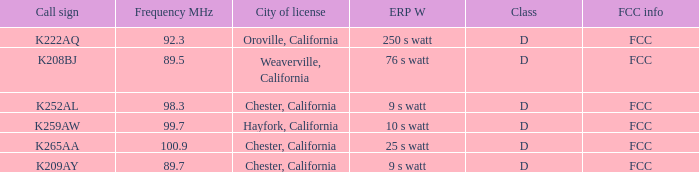Can you parse all the data within this table? {'header': ['Call sign', 'Frequency MHz', 'City of license', 'ERP W', 'Class', 'FCC info'], 'rows': [['K222AQ', '92.3', 'Oroville, California', '250 s watt', 'D', 'FCC'], ['K208BJ', '89.5', 'Weaverville, California', '76 s watt', 'D', 'FCC'], ['K252AL', '98.3', 'Chester, California', '9 s watt', 'D', 'FCC'], ['K259AW', '99.7', 'Hayfork, California', '10 s watt', 'D', 'FCC'], ['K265AA', '100.9', 'Chester, California', '25 s watt', 'D', 'FCC'], ['K209AY', '89.7', 'Chester, California', '9 s watt', 'D', 'FCC']]} Name the call sign with frequency of 89.5 K208BJ. 